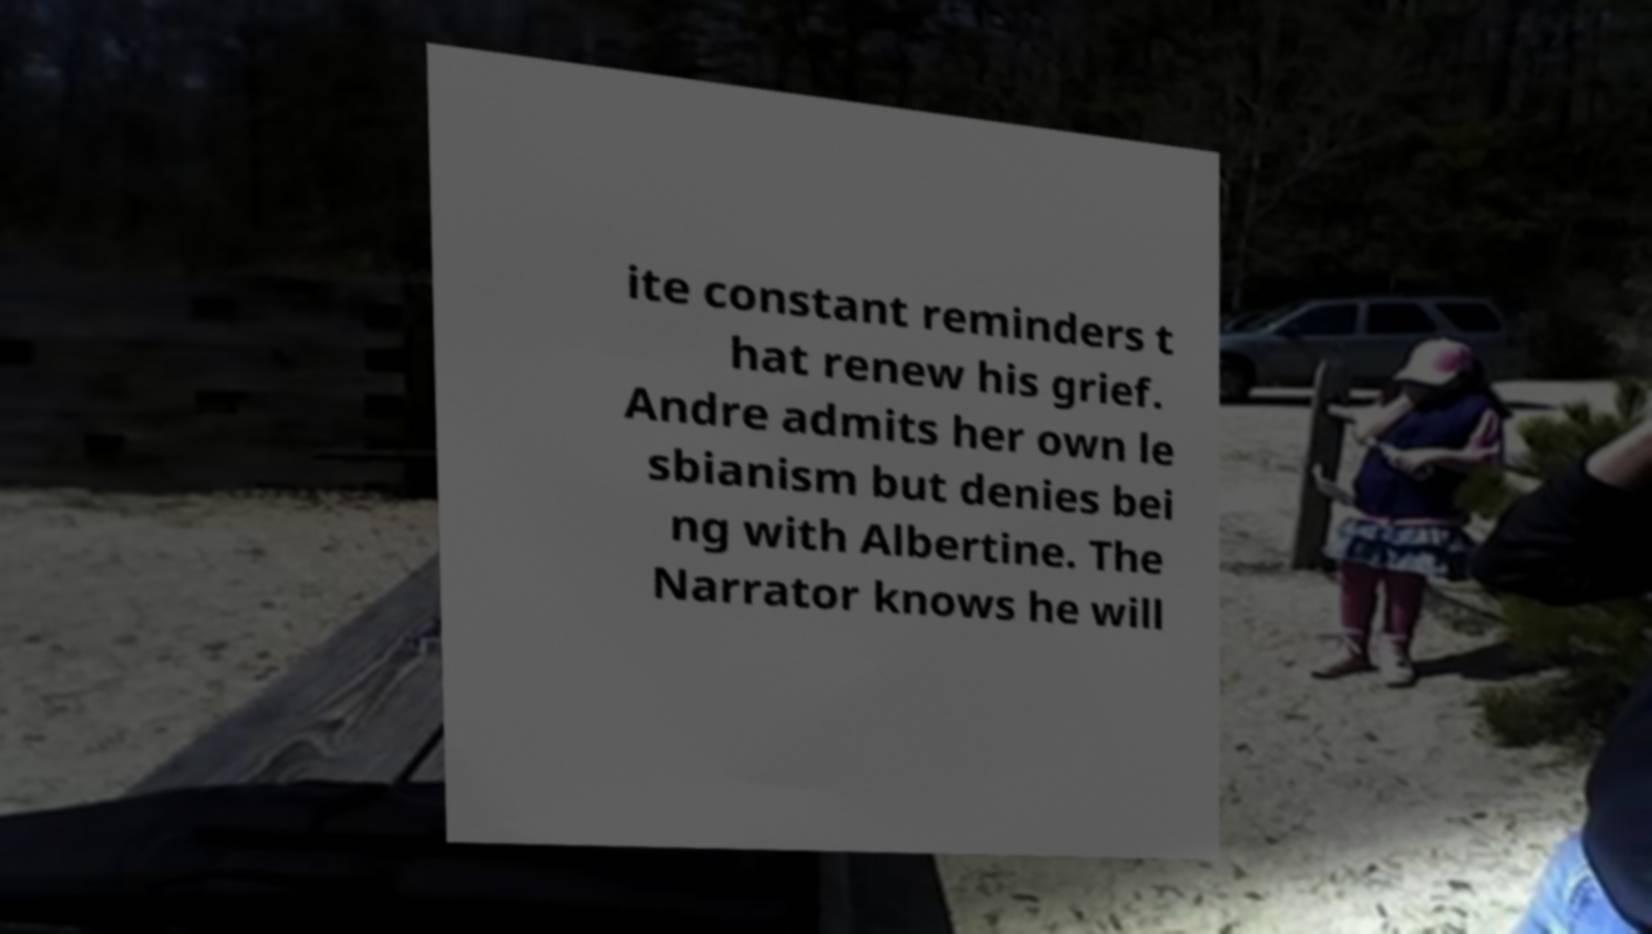Could you extract and type out the text from this image? ite constant reminders t hat renew his grief. Andre admits her own le sbianism but denies bei ng with Albertine. The Narrator knows he will 